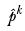<formula> <loc_0><loc_0><loc_500><loc_500>\hat { p } ^ { k }</formula> 